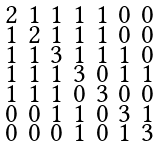Convert formula to latex. <formula><loc_0><loc_0><loc_500><loc_500>\begin{smallmatrix} 2 & 1 & 1 & 1 & 1 & 0 & 0 \\ 1 & 2 & 1 & 1 & 1 & 0 & 0 \\ 1 & 1 & 3 & 1 & 1 & 1 & 0 \\ 1 & 1 & 1 & 3 & 0 & 1 & 1 \\ 1 & 1 & 1 & 0 & 3 & 0 & 0 \\ 0 & 0 & 1 & 1 & 0 & 3 & 1 \\ 0 & 0 & 0 & 1 & 0 & 1 & 3 \end{smallmatrix}</formula> 